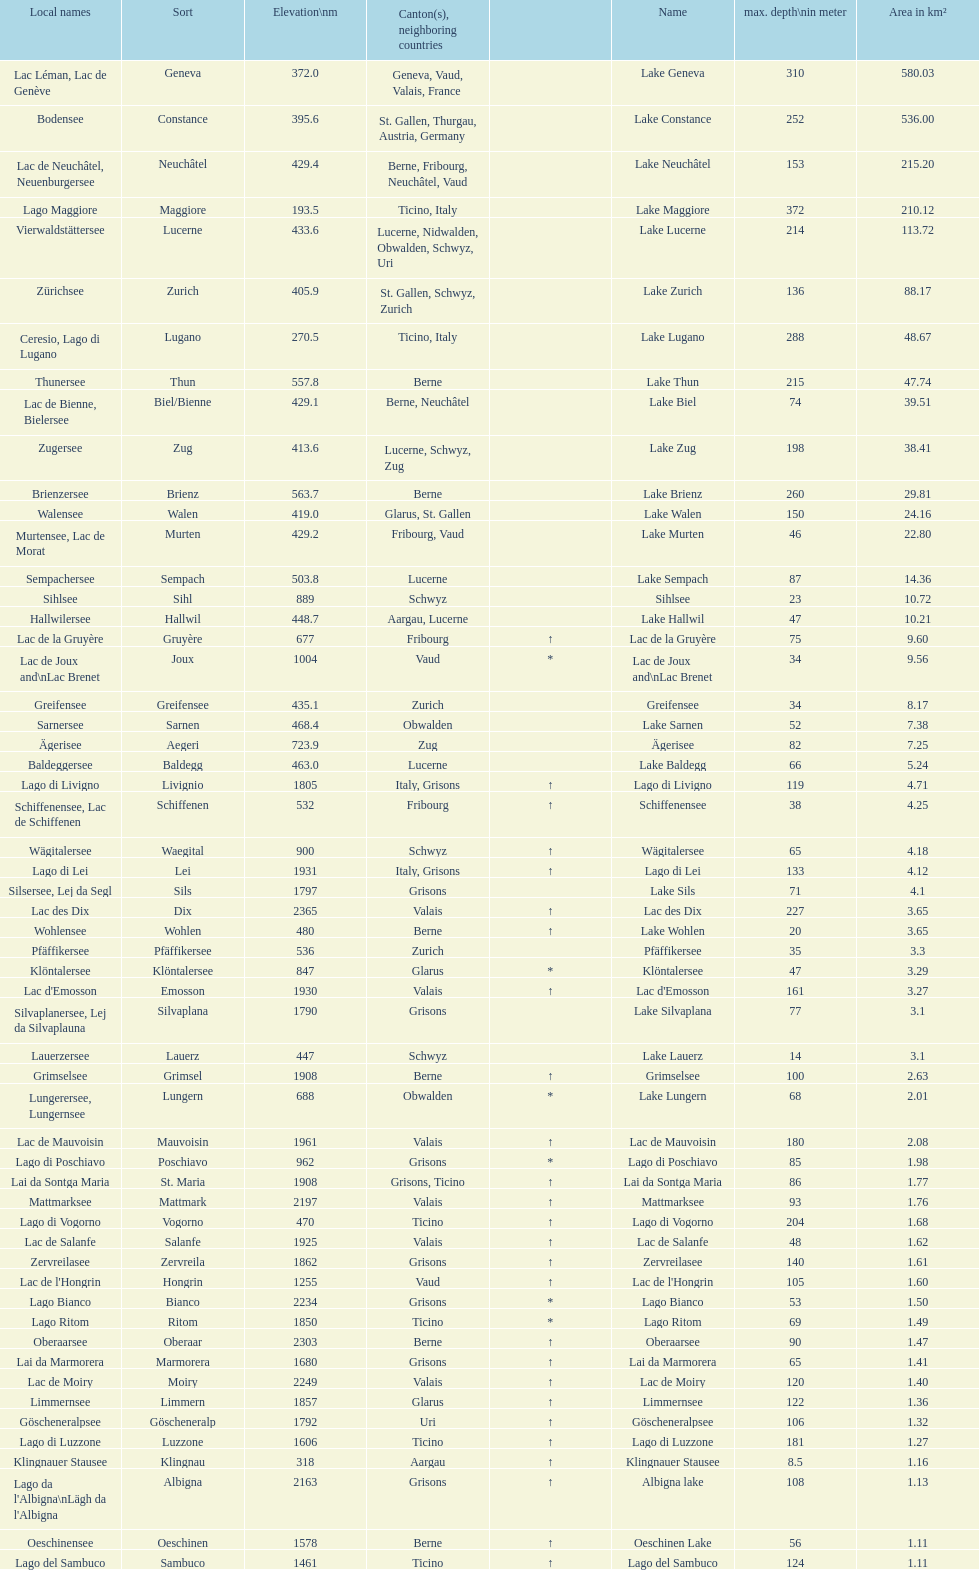Which lake has at least 580 area in km²? Lake Geneva. 